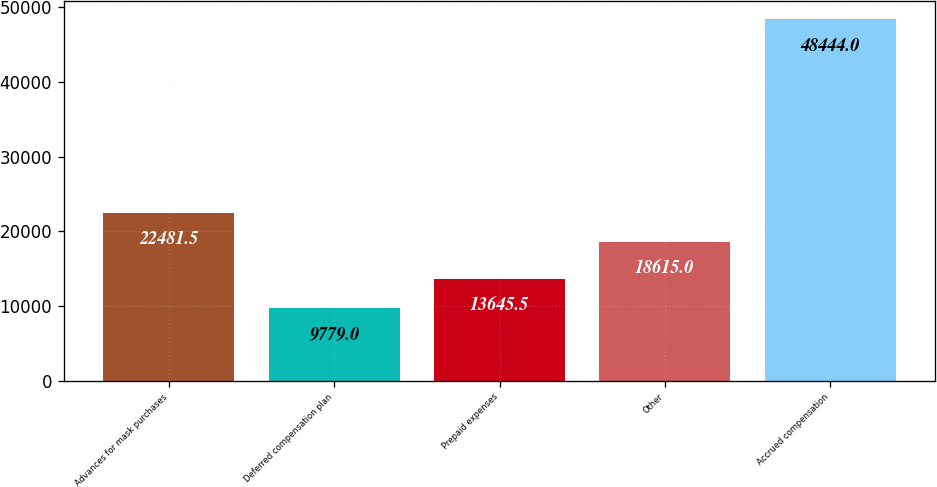<chart> <loc_0><loc_0><loc_500><loc_500><bar_chart><fcel>Advances for mask purchases<fcel>Deferred compensation plan<fcel>Prepaid expenses<fcel>Other<fcel>Accrued compensation<nl><fcel>22481.5<fcel>9779<fcel>13645.5<fcel>18615<fcel>48444<nl></chart> 